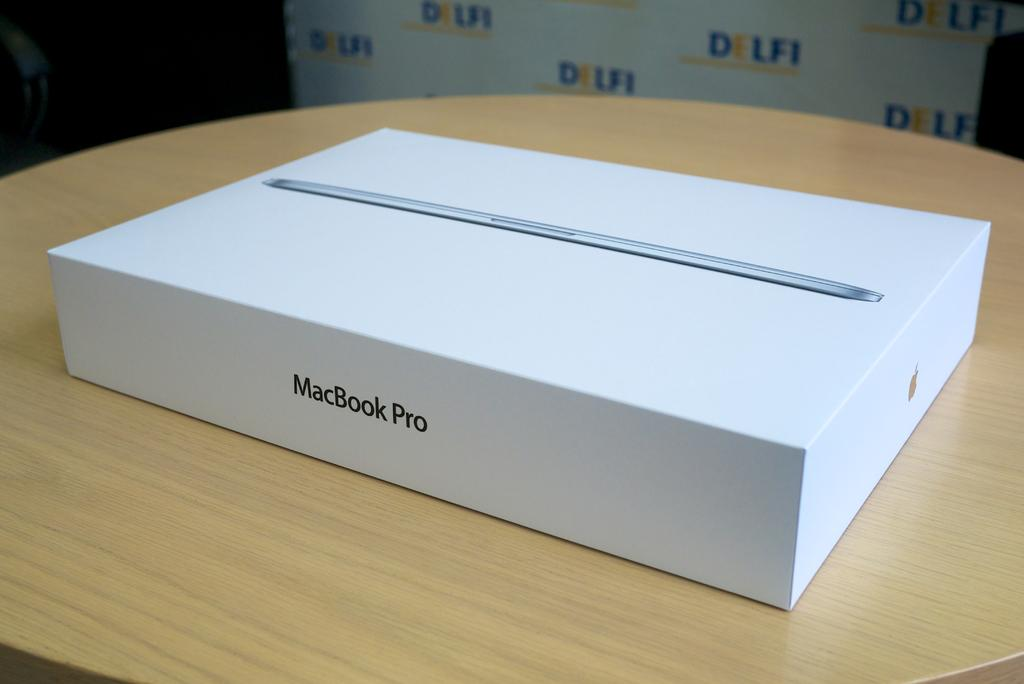<image>
Present a compact description of the photo's key features. A white box shows that it contains a Macbook Pro. 